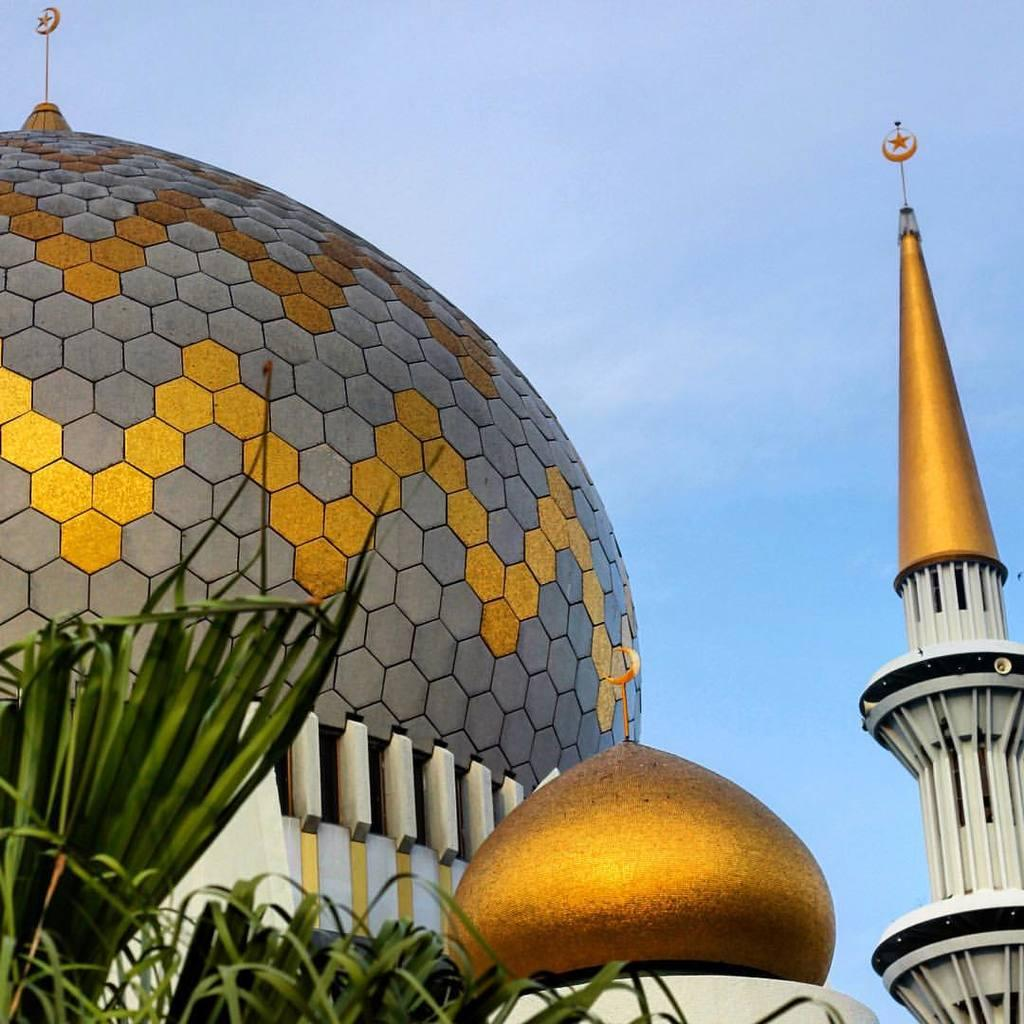What type of structure is visible in the image? There is a dome in the image. What architectural elements support the dome? There are pillars in the image. What type of vegetation is present in the image? There are plants in the image. What is visible in the background of the image? The sky is visible in the image. How many brothers are depicted in the image? There are no brothers present in the image; it features a dome, pillars, plants, and the sky. What type of horse can be seen grazing in the image? There is no horse present in the image; it features a dome, pillars, plants, and the sky. 